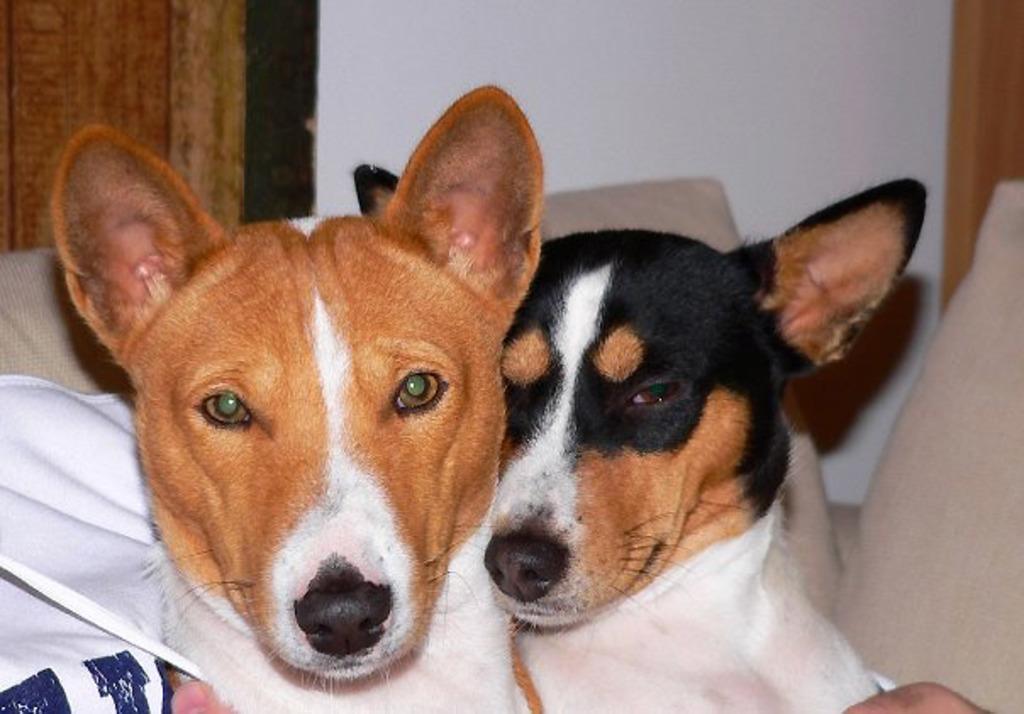Describe this image in one or two sentences. In this image we can see a person sitting on a sofa holding the dogs. We can also see some cushions and a wall. 